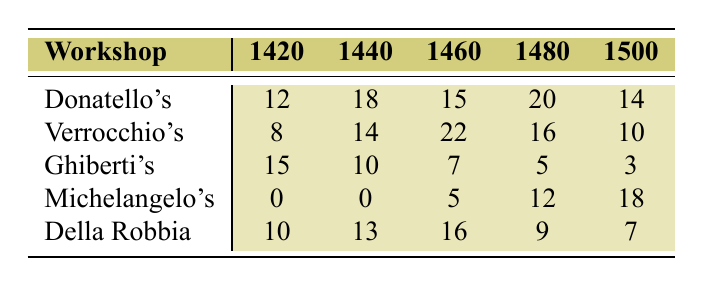What is the highest number of apprentices in Donatello's Workshop? Referring to the table, Donatello's Workshop has the highest number of apprentices in 1480 with 20 apprentices.
Answer: 20 How many apprentices did Verrocchio's Workshop have in 1460? The table shows that Verrocchio's Workshop had 22 apprentices in 1460.
Answer: 22 What was the total number of apprentices in Michelangelo's Workshop from 1420 to 1500? Adding the values from Michelangelo's Workshop: 0 (1420) + 0 (1440) + 5 (1460) + 12 (1480) + 18 (1500) = 35 gives the total.
Answer: 35 Which workshop had the least number of apprentices in 1500? In 1500, Ghiberti's Workshop had the least number of apprentices, with only 3.
Answer: Ghiberti's Workshop What is the average number of apprentices in Della Robbia Workshop across all years? To find the average, sum the values (10 + 13 + 16 + 9 + 7 = 55) and divide by the number of years (5). Hence, 55 / 5 = 11.
Answer: 11 True or False: Ghiberti's Workshop had more apprentices in 1420 than in 1440. The table shows Ghiberti's Workshop had 15 apprentices in 1420 and 10 in 1440, indicating it had fewer apprentices in 1440. Thus, the statement is False.
Answer: False Which workshop had the most consistent number of apprentices across the years? By analyzing the data, Ghiberti's Workshop shows a steady decline over the years (15, 10, 7, 5, 3), indicating it lacked consistency, while others like Donatello's show fluctuation but not a consistent trend. Verrocchio’s Workshop shows varying numbers, making it less consistent compared to Ghiberti's decline.
Answer: No workshop What is the difference in the number of apprentices between the highest and lowest years for Donatello's Workshop? The highest number (20 in 1480) minus the lowest (12 in 1420) gives: 20 - 12 = 8.
Answer: 8 What percentage of the total number of apprentices from all workshops in 1440 did Verrocchio's Workshop represent? First, sum the apprentices in 1440: 18 (Donatello) + 14 (Verrocchio) + 10 (Ghiberti) + 0 (Michelangelo) + 13 (Della Robbia) = 55. Then, Verrocchio's share: (14/55) * 100 = 25.45%.
Answer: ~25.45% Which workshop had an increase in apprentices between 1460 and 1480? Comparing the numbers, Michelangelo's Workshop increased from 5 (1460) to 12 (1480), indicating an increase.
Answer: Michelangelo's Workshop 